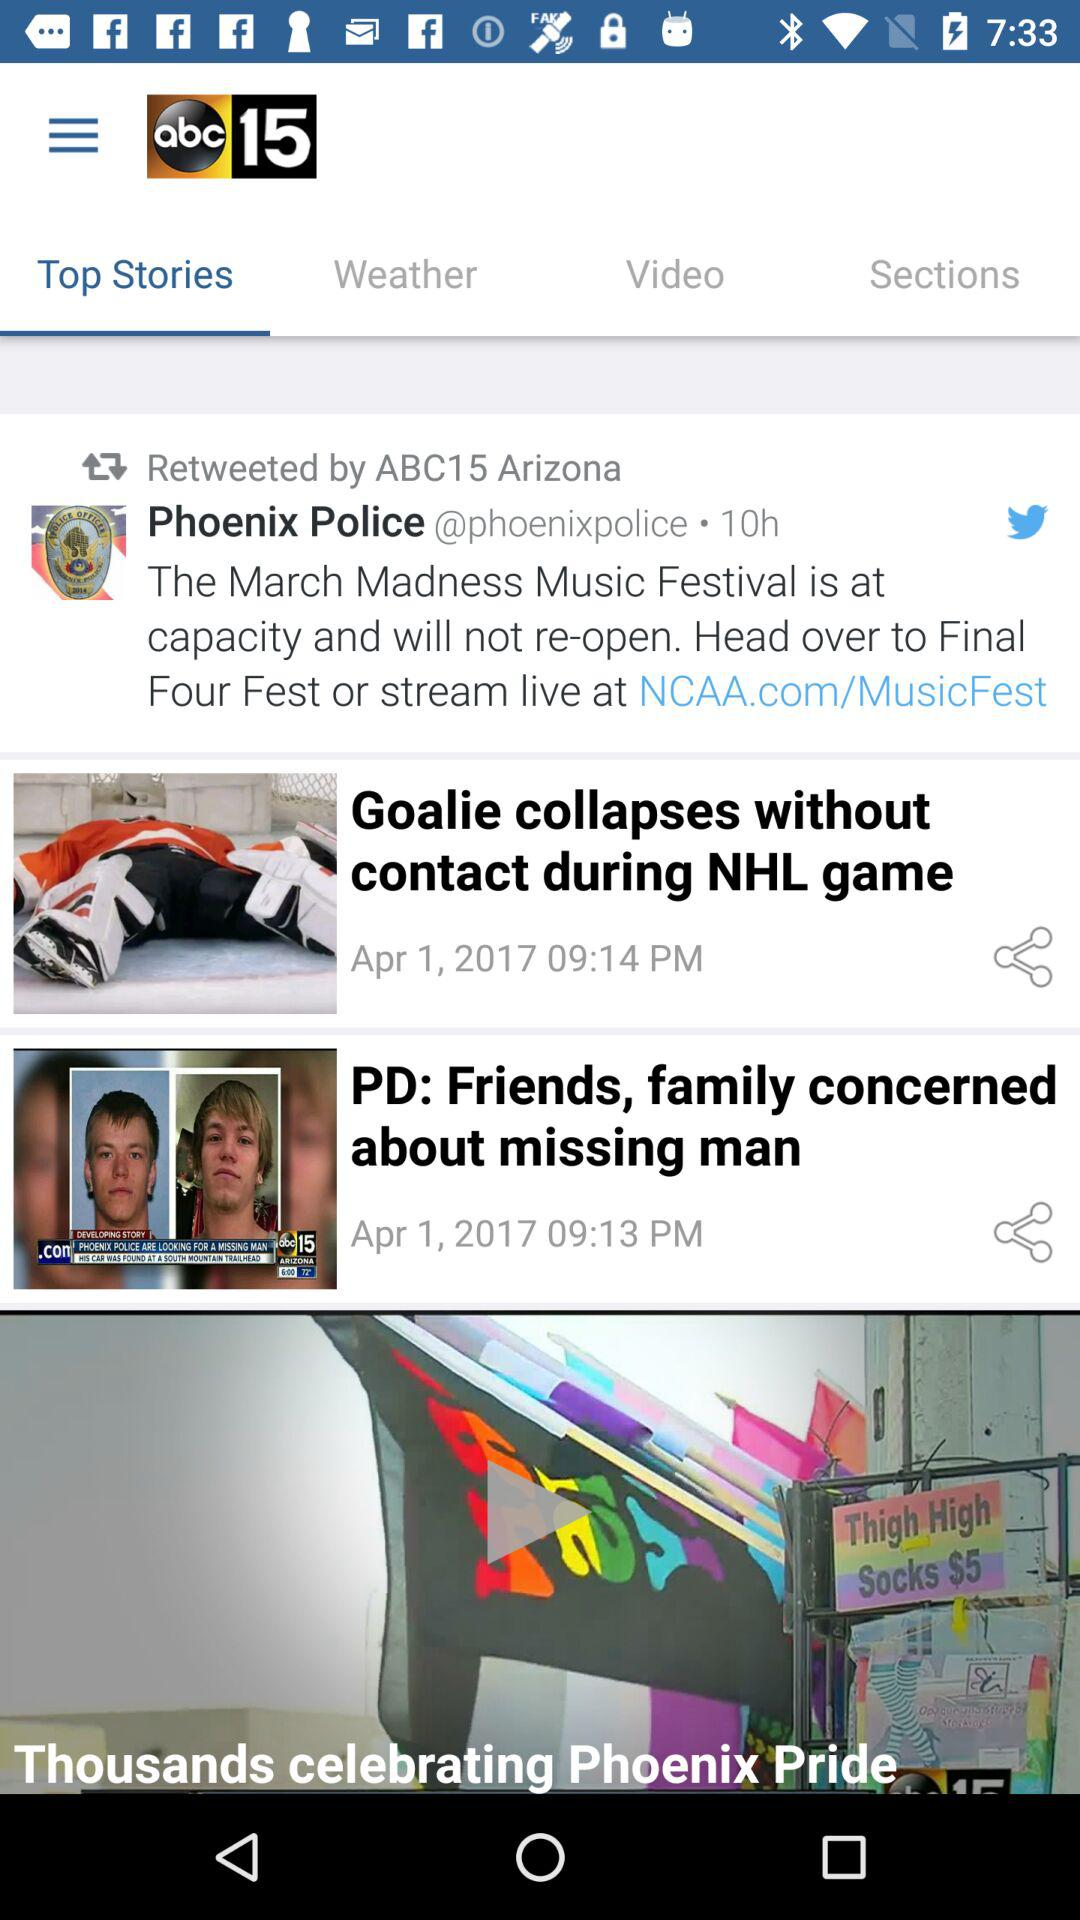What is the application name? The application name is "abc15". 